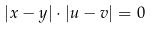Convert formula to latex. <formula><loc_0><loc_0><loc_500><loc_500>| x - y | \cdot | u - v | = 0</formula> 